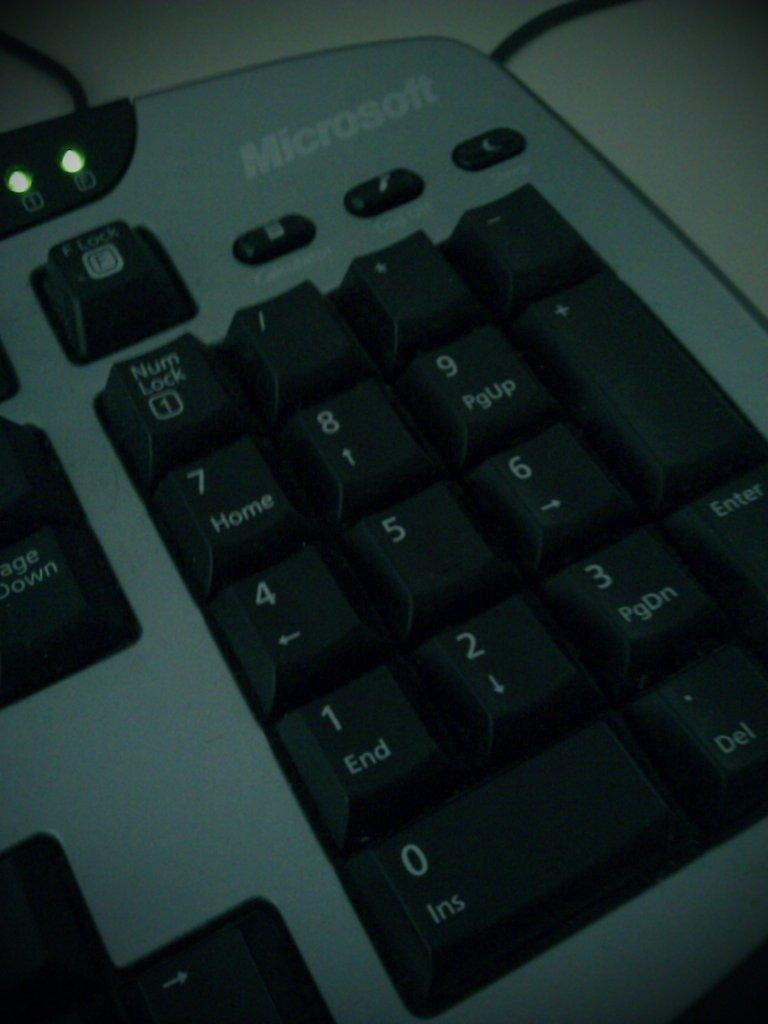<image>
Offer a succinct explanation of the picture presented. A ten key on a keyboard with bottom left key labeled Ins 